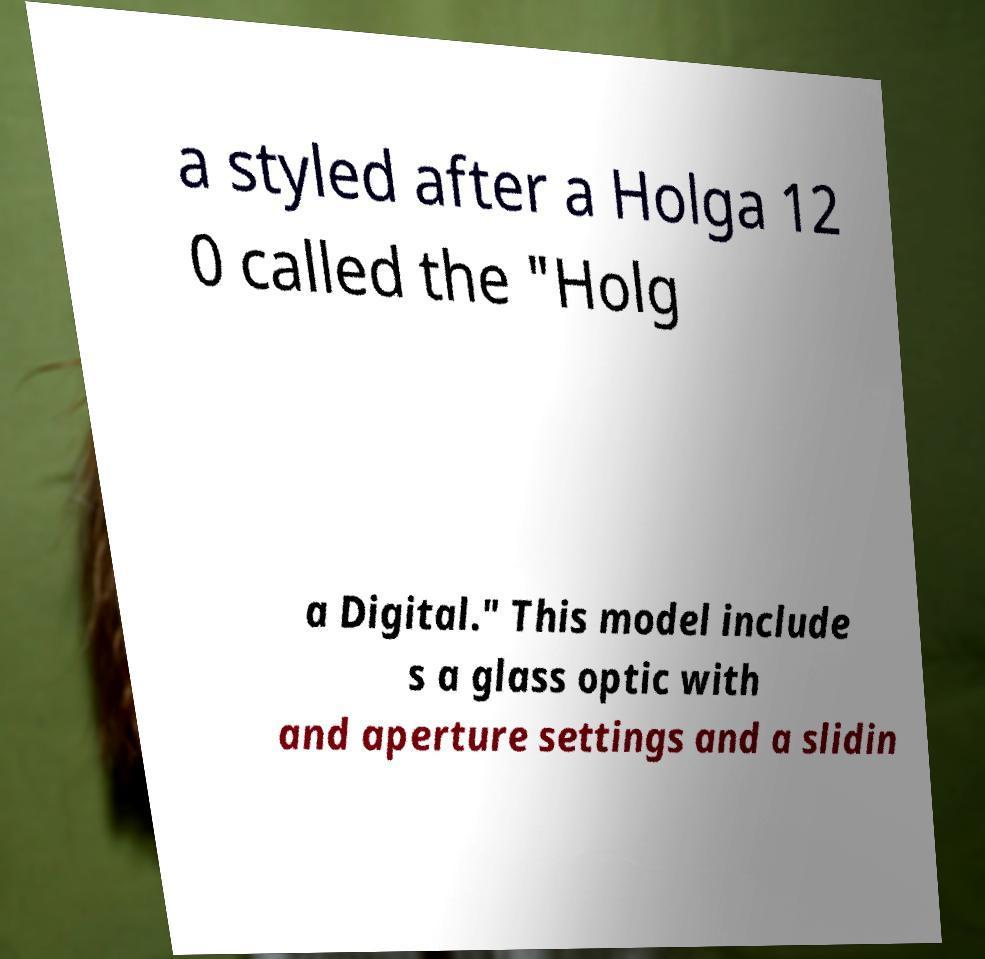Please read and relay the text visible in this image. What does it say? a styled after a Holga 12 0 called the "Holg a Digital." This model include s a glass optic with and aperture settings and a slidin 